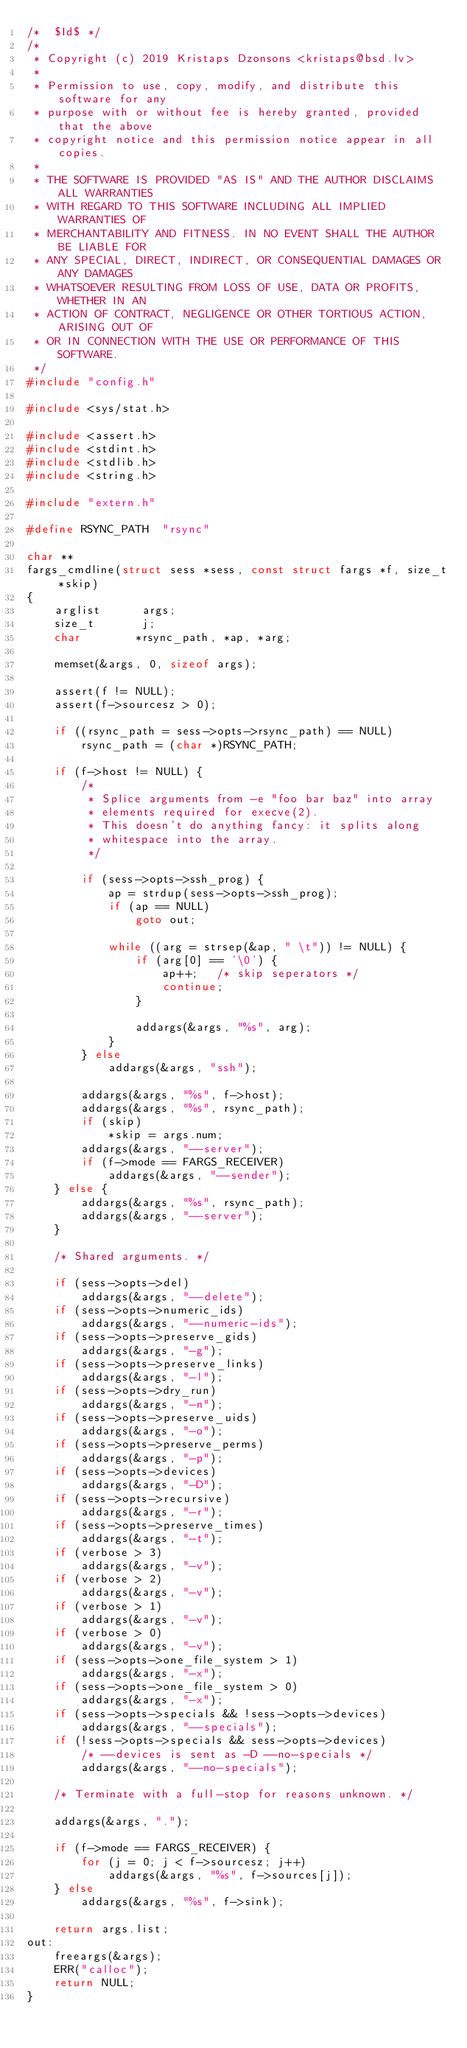Convert code to text. <code><loc_0><loc_0><loc_500><loc_500><_C_>/*	$Id$ */
/*
 * Copyright (c) 2019 Kristaps Dzonsons <kristaps@bsd.lv>
 *
 * Permission to use, copy, modify, and distribute this software for any
 * purpose with or without fee is hereby granted, provided that the above
 * copyright notice and this permission notice appear in all copies.
 *
 * THE SOFTWARE IS PROVIDED "AS IS" AND THE AUTHOR DISCLAIMS ALL WARRANTIES
 * WITH REGARD TO THIS SOFTWARE INCLUDING ALL IMPLIED WARRANTIES OF
 * MERCHANTABILITY AND FITNESS. IN NO EVENT SHALL THE AUTHOR BE LIABLE FOR
 * ANY SPECIAL, DIRECT, INDIRECT, OR CONSEQUENTIAL DAMAGES OR ANY DAMAGES
 * WHATSOEVER RESULTING FROM LOSS OF USE, DATA OR PROFITS, WHETHER IN AN
 * ACTION OF CONTRACT, NEGLIGENCE OR OTHER TORTIOUS ACTION, ARISING OUT OF
 * OR IN CONNECTION WITH THE USE OR PERFORMANCE OF THIS SOFTWARE.
 */
#include "config.h"

#include <sys/stat.h>

#include <assert.h>
#include <stdint.h>
#include <stdlib.h>
#include <string.h>

#include "extern.h"

#define	RSYNC_PATH	"rsync"

char **
fargs_cmdline(struct sess *sess, const struct fargs *f, size_t *skip)
{
	arglist		 args;
	size_t		 j;
	char		*rsync_path, *ap, *arg;

	memset(&args, 0, sizeof args);

	assert(f != NULL);
	assert(f->sourcesz > 0);

	if ((rsync_path = sess->opts->rsync_path) == NULL)
		rsync_path = (char *)RSYNC_PATH;

	if (f->host != NULL) {
		/*
		 * Splice arguments from -e "foo bar baz" into array
		 * elements required for execve(2).
		 * This doesn't do anything fancy: it splits along
		 * whitespace into the array.
		 */

		if (sess->opts->ssh_prog) {
			ap = strdup(sess->opts->ssh_prog);
			if (ap == NULL)
				goto out;

			while ((arg = strsep(&ap, " \t")) != NULL) {
				if (arg[0] == '\0') {
					ap++;	/* skip seperators */
					continue;
				}

				addargs(&args, "%s", arg);
			}
		} else
			addargs(&args, "ssh");

		addargs(&args, "%s", f->host);
		addargs(&args, "%s", rsync_path);
		if (skip)
			*skip = args.num;
		addargs(&args, "--server");
		if (f->mode == FARGS_RECEIVER)
			addargs(&args, "--sender");
	} else {
		addargs(&args, "%s", rsync_path);
		addargs(&args, "--server");
	}

	/* Shared arguments. */

	if (sess->opts->del)
		addargs(&args, "--delete");
	if (sess->opts->numeric_ids)
		addargs(&args, "--numeric-ids");
	if (sess->opts->preserve_gids)
		addargs(&args, "-g");
	if (sess->opts->preserve_links)
		addargs(&args, "-l");
	if (sess->opts->dry_run)
		addargs(&args, "-n");
	if (sess->opts->preserve_uids)
		addargs(&args, "-o");
	if (sess->opts->preserve_perms)
		addargs(&args, "-p");
	if (sess->opts->devices)
		addargs(&args, "-D");
	if (sess->opts->recursive)
		addargs(&args, "-r");
	if (sess->opts->preserve_times)
		addargs(&args, "-t");
	if (verbose > 3)
		addargs(&args, "-v");
	if (verbose > 2)
		addargs(&args, "-v");
	if (verbose > 1)
		addargs(&args, "-v");
	if (verbose > 0)
		addargs(&args, "-v");
	if (sess->opts->one_file_system > 1)
		addargs(&args, "-x");
	if (sess->opts->one_file_system > 0)
		addargs(&args, "-x");
	if (sess->opts->specials && !sess->opts->devices)
		addargs(&args, "--specials");
	if (!sess->opts->specials && sess->opts->devices)
		/* --devices is sent as -D --no-specials */
		addargs(&args, "--no-specials");

	/* Terminate with a full-stop for reasons unknown. */

	addargs(&args, ".");

	if (f->mode == FARGS_RECEIVER) {
		for (j = 0; j < f->sourcesz; j++)
			addargs(&args, "%s", f->sources[j]);
	} else
		addargs(&args, "%s", f->sink);

	return args.list;
out:
	freeargs(&args);
	ERR("calloc");
	return NULL;
}
</code> 